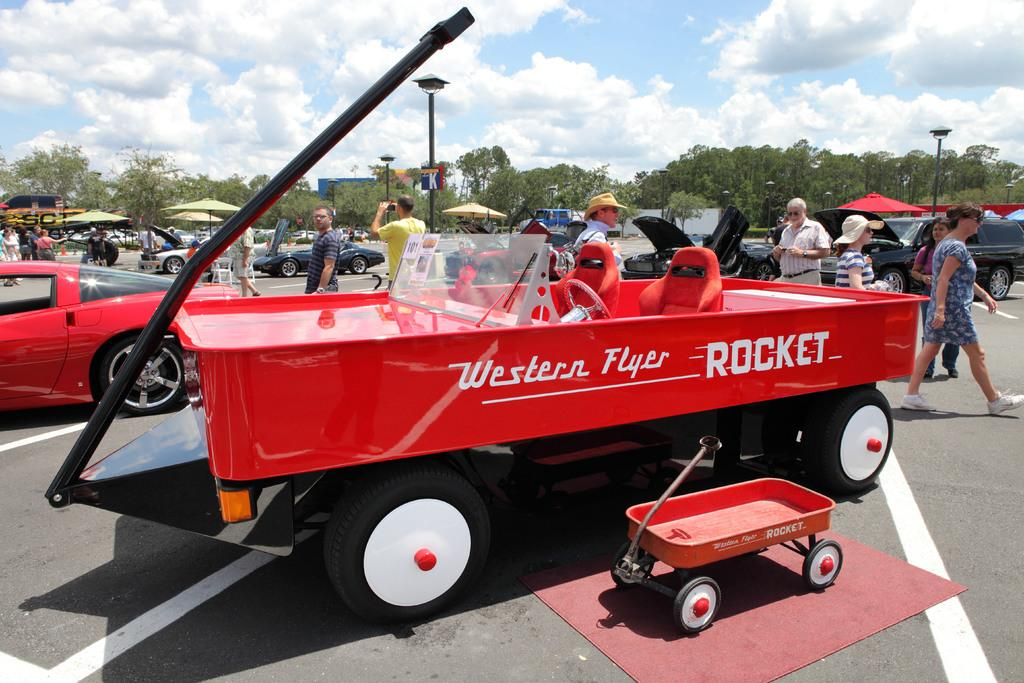What types of vehicles can be seen in the image? There are vehicles in the image, but the specific types are not mentioned. What is the cart used for in the image? The purpose of the cart in the image is not specified. What is the mat used for in the image? The purpose of the mat in the image is not specified. How many people are present in the image? There are people in the image, but the exact number is not mentioned. What are the light poles used for in the image? The purpose of the light poles in the image is not specified. What message or information is displayed on the signboard in the image? The content of the signboard in the image is not mentioned. What type of trees are visible in the image? The type of trees in the image is not specified. What is the weather like in the image? The sky is cloudy in the image, suggesting a partly cloudy or overcast day. What are the umbrellas used for in the image? The purpose of the umbrellas in the image is not specified. What type of advertisements or promotions are displayed on the hoardings in the image? The content of the hoardings in the image is not mentioned. How many eyes can be seen on the education poster in the image? There is no education poster present in the image, and therefore no eyes can be counted. 